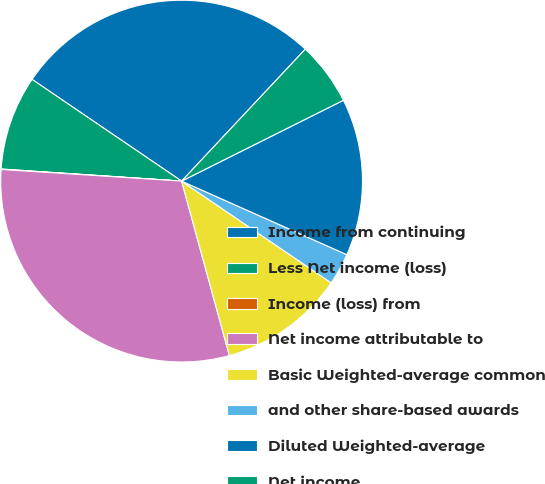Convert chart to OTSL. <chart><loc_0><loc_0><loc_500><loc_500><pie_chart><fcel>Income from continuing<fcel>Less Net income (loss)<fcel>Income (loss) from<fcel>Net income attributable to<fcel>Basic Weighted-average common<fcel>and other share-based awards<fcel>Diluted Weighted-average<fcel>Net income<nl><fcel>27.48%<fcel>8.44%<fcel>0.04%<fcel>30.28%<fcel>11.24%<fcel>2.84%<fcel>14.04%<fcel>5.64%<nl></chart> 